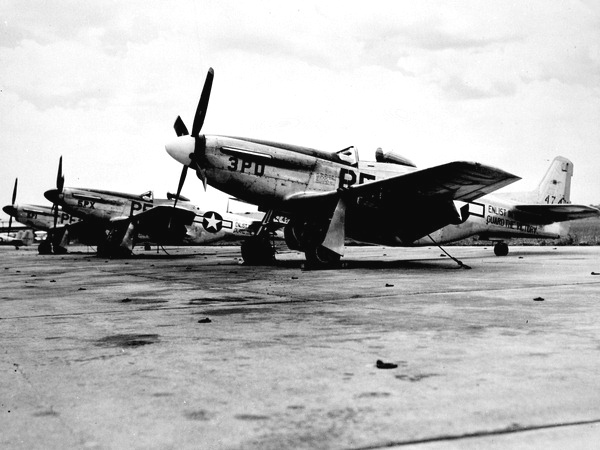Are these planes capable of long-distance flights? Indeed, the P-51 Mustangs were known for their long-range capabilities. They served as bomber escorts on numerous missions during World War II, including vital operations over Germany. Their extended range was key in enabling Allied bombers to reach their targets with fewer losses to enemy fighters. What was the impact of these aircraft in the war? The introduction of the P-51 Mustangs had a significant and pivotal impact on the air battles of World War II. They played a crucial role in gaining aerial superiority over Europe, which helped to decrease the loss rate of Allied bombers and ultimately contributed to the success of the air war against Nazi Germany. 